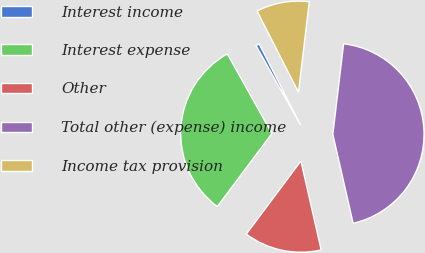Convert chart to OTSL. <chart><loc_0><loc_0><loc_500><loc_500><pie_chart><fcel>Interest income<fcel>Interest expense<fcel>Other<fcel>Total other (expense) income<fcel>Income tax provision<nl><fcel>0.62%<fcel>31.66%<fcel>13.78%<fcel>44.54%<fcel>9.39%<nl></chart> 